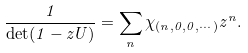<formula> <loc_0><loc_0><loc_500><loc_500>\frac { 1 } { \det ( 1 - z U ) } = \sum _ { n } \chi _ { ( n , 0 , 0 , \cdots ) } z ^ { n } .</formula> 